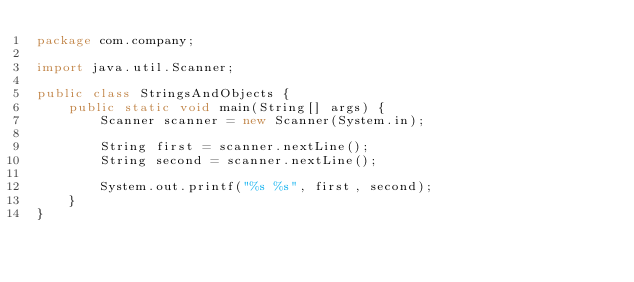Convert code to text. <code><loc_0><loc_0><loc_500><loc_500><_Java_>package com.company;

import java.util.Scanner;

public class StringsAndObjects {
    public static void main(String[] args) {
        Scanner scanner = new Scanner(System.in);

        String first = scanner.nextLine();
        String second = scanner.nextLine();

        System.out.printf("%s %s", first, second);
    }
}
</code> 